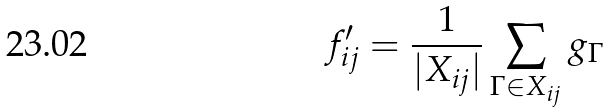Convert formula to latex. <formula><loc_0><loc_0><loc_500><loc_500>f _ { i j } ^ { \prime } = \frac { 1 } { | X _ { i j } | } \sum _ { \Gamma \in X _ { i j } } g _ { \Gamma }</formula> 